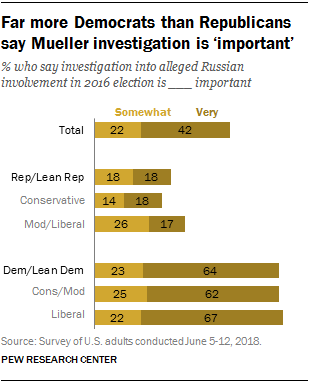Draw attention to some important aspects in this diagram. The total of "Very" responses is 0.42%. The ratio of the total of "Very" to "Somewhat" is 1.765277778... 